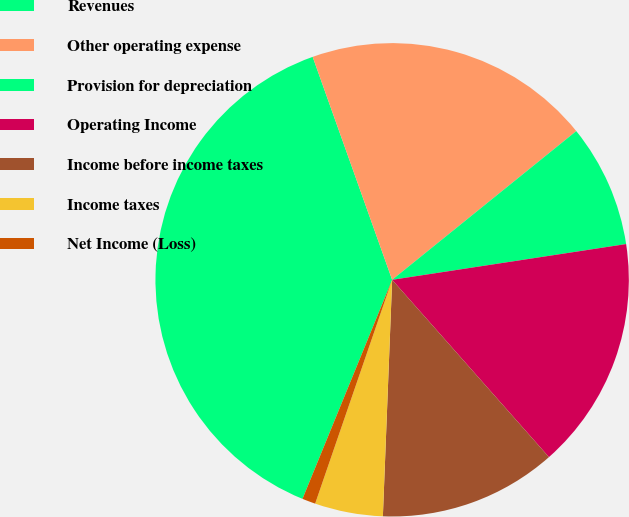Convert chart to OTSL. <chart><loc_0><loc_0><loc_500><loc_500><pie_chart><fcel>Revenues<fcel>Other operating expense<fcel>Provision for depreciation<fcel>Operating Income<fcel>Income before income taxes<fcel>Income taxes<fcel>Net Income (Loss)<nl><fcel>38.37%<fcel>19.64%<fcel>8.4%<fcel>15.89%<fcel>12.15%<fcel>4.65%<fcel>0.91%<nl></chart> 